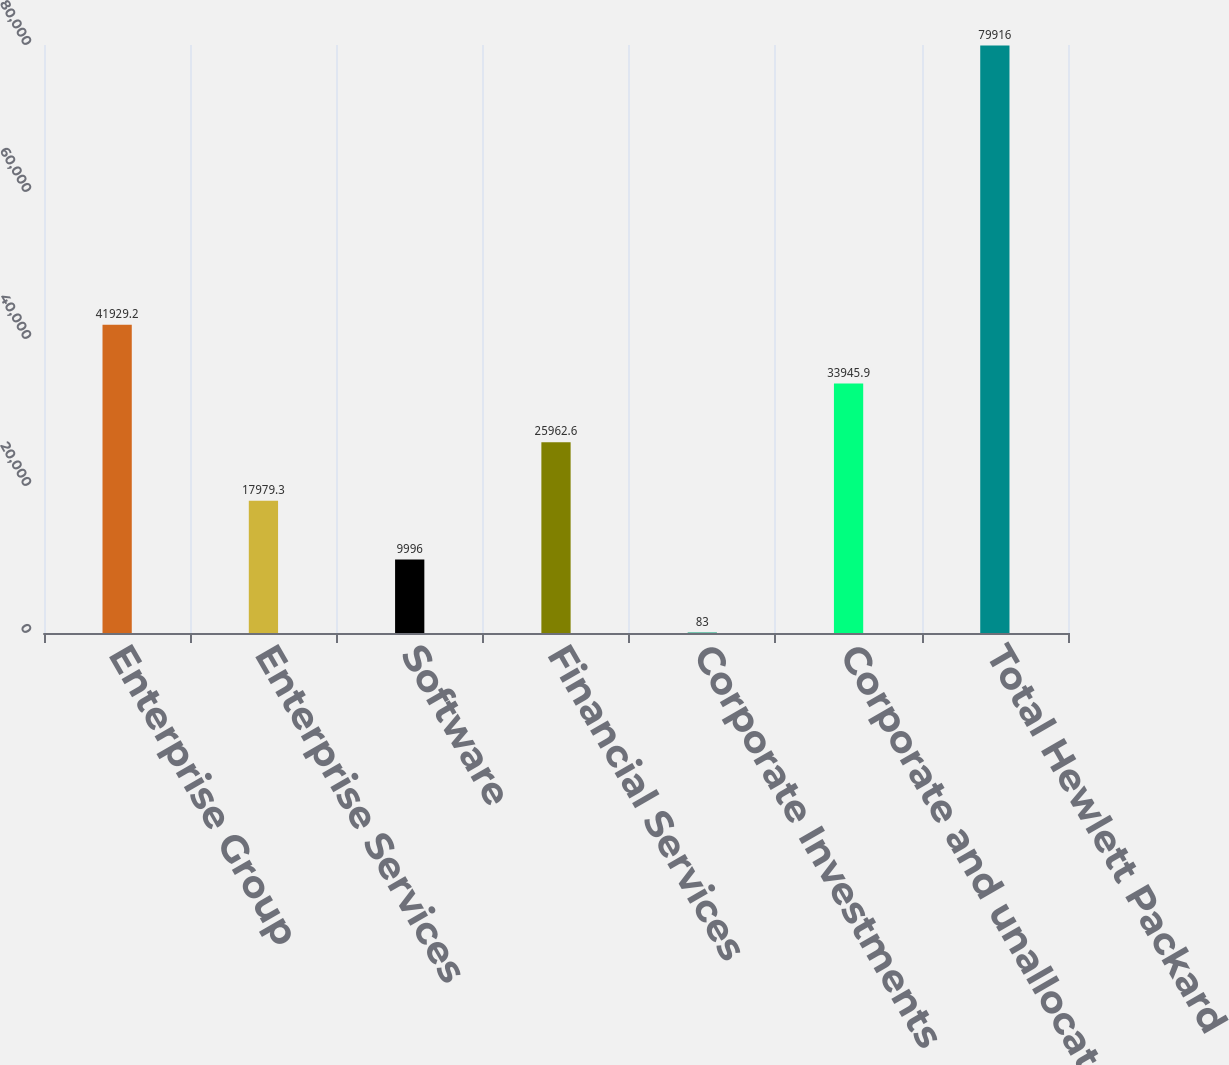Convert chart to OTSL. <chart><loc_0><loc_0><loc_500><loc_500><bar_chart><fcel>Enterprise Group<fcel>Enterprise Services<fcel>Software<fcel>Financial Services<fcel>Corporate Investments<fcel>Corporate and unallocated<fcel>Total Hewlett Packard<nl><fcel>41929.2<fcel>17979.3<fcel>9996<fcel>25962.6<fcel>83<fcel>33945.9<fcel>79916<nl></chart> 